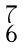<formula> <loc_0><loc_0><loc_500><loc_500>\begin{smallmatrix} 7 \\ 6 \end{smallmatrix}</formula> 